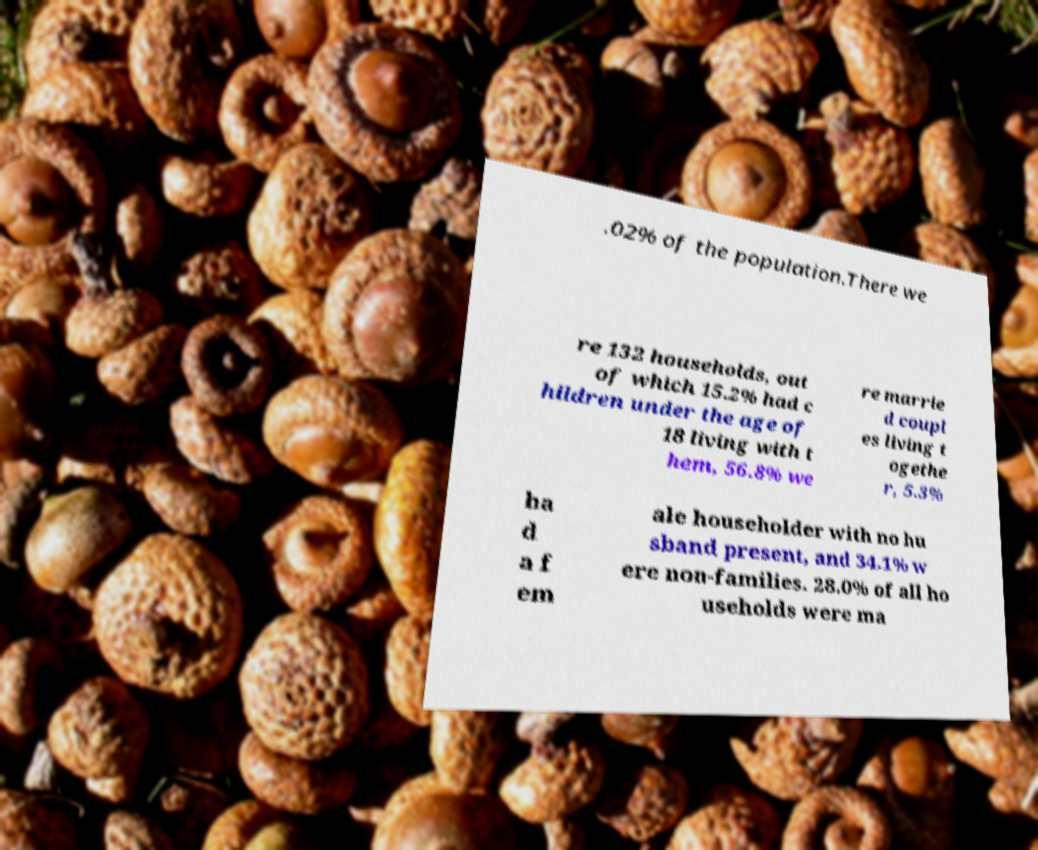Can you read and provide the text displayed in the image?This photo seems to have some interesting text. Can you extract and type it out for me? .02% of the population.There we re 132 households, out of which 15.2% had c hildren under the age of 18 living with t hem, 56.8% we re marrie d coupl es living t ogethe r, 5.3% ha d a f em ale householder with no hu sband present, and 34.1% w ere non-families. 28.0% of all ho useholds were ma 